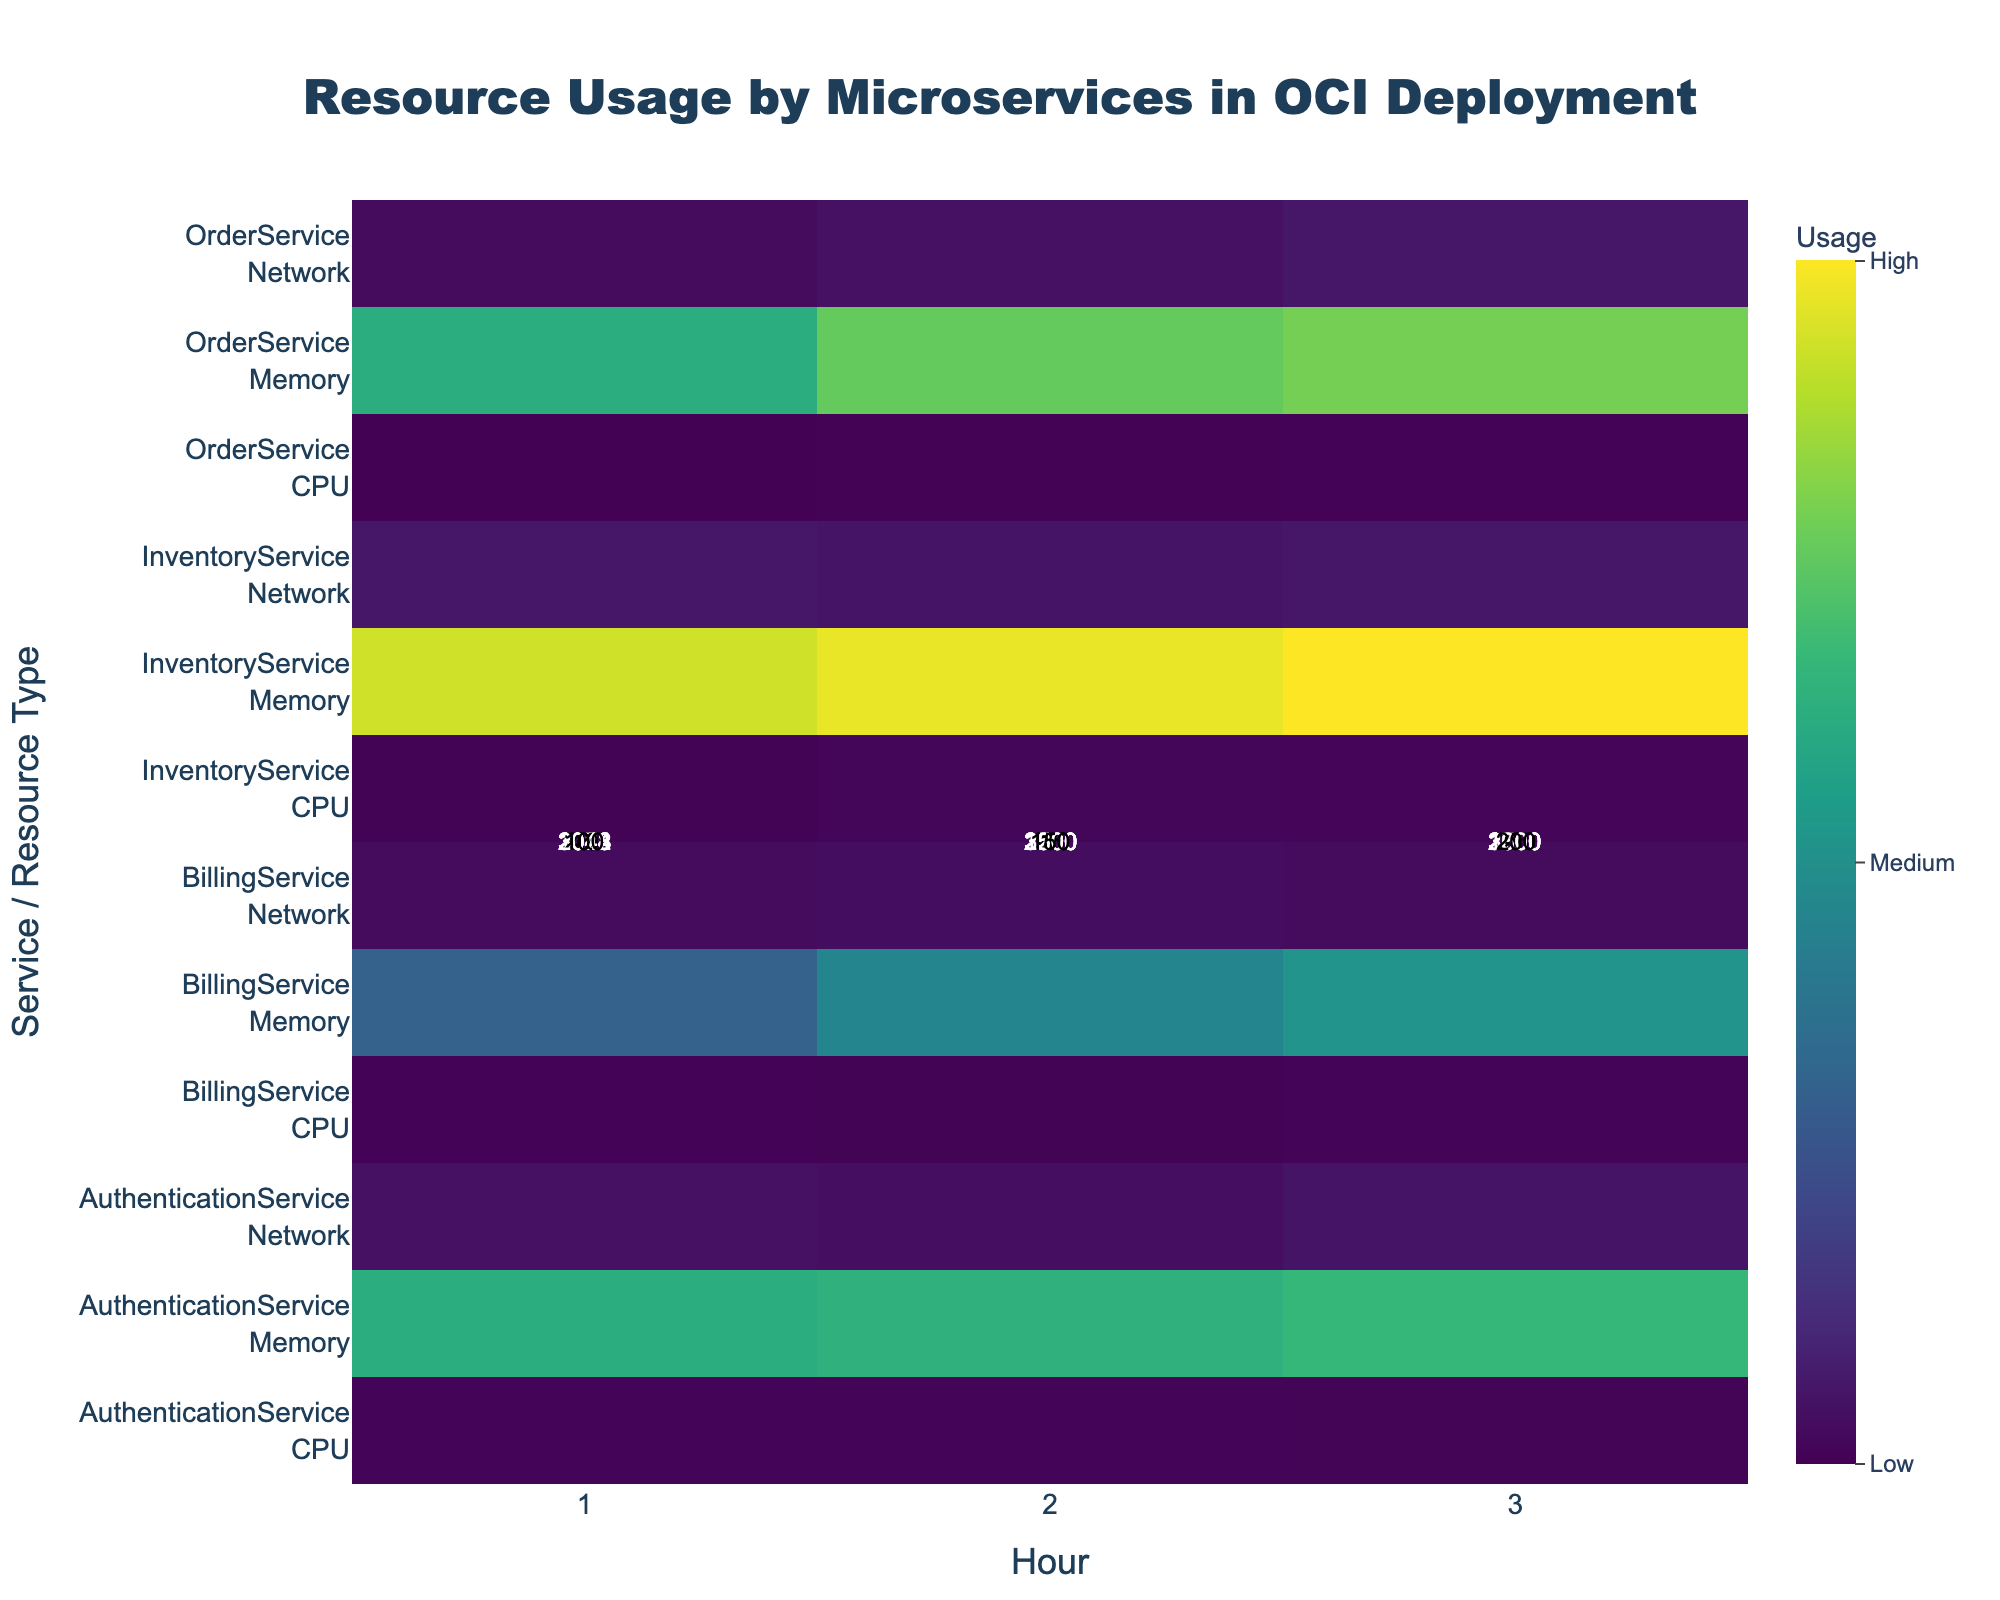what is the highest CPU usage of AuthenticationService? Locate the row for AuthenticationService and the column for CPU usages. Identify the highest value listed under CPU usage for different hours.
Answer: 40 Which service had the highest memory usage at hour 3? Locate the column for hour 3 and check the memory usage for each service. Identify the service with the highest value.
Answer: InventoryService At what hour did OrderService have the highest network usage? Locate the row for OrderService and check the network usage values for different hours. Identify the hour with the highest value.
Answer: Hour 3 What is the combined CPU usage of InventoryService over hours 1, 2, and 3? Locate the row for InventoryService and the column for CPU usages. Sum the CPU usages listed for hours 1, 2, and 3.
Answer: 120 Which resource type has the most variable usage in BillingService? Look at the usage values for CPU, Memory, and Network in BillingService. Identify the resource type with the largest difference between highest and lowest values.
Answer: Memory How does the network usage of InventoryService compare to AuthenticationService at hour 1? Locate the network usage values for InventoryService and AuthenticationService at hour 1. Compare these two values to identify which is greater.
Answer: InventoryService has higher network usage What is the difference in memory usage between hour 2 and hour 1 for OrderService? Locate the memory usage values for OrderService at hours 2 and 1. Subtract the value at hour 1 from the value at hour 2.
Answer: 452 Which service had the lowest total CPU usage across all hours? Sum the CPU usage values for each service across all hours. Identify the service with the lowest total sum.
Answer: OrderService What is the average network usage for AuthenticationService across all hours? Locate the network usage values for AuthenticationService across all hours. Calculate the average by summing these values and dividing by the number of hours.
Answer: 150 How does the heatmap indicate the intensity of resource usage? Look at the color scale on the heatmap. Determine what color represents high usage and low usage, and describe how the intensity is visually displayed.
Answer: Colors range from dark (low) to bright (high) 